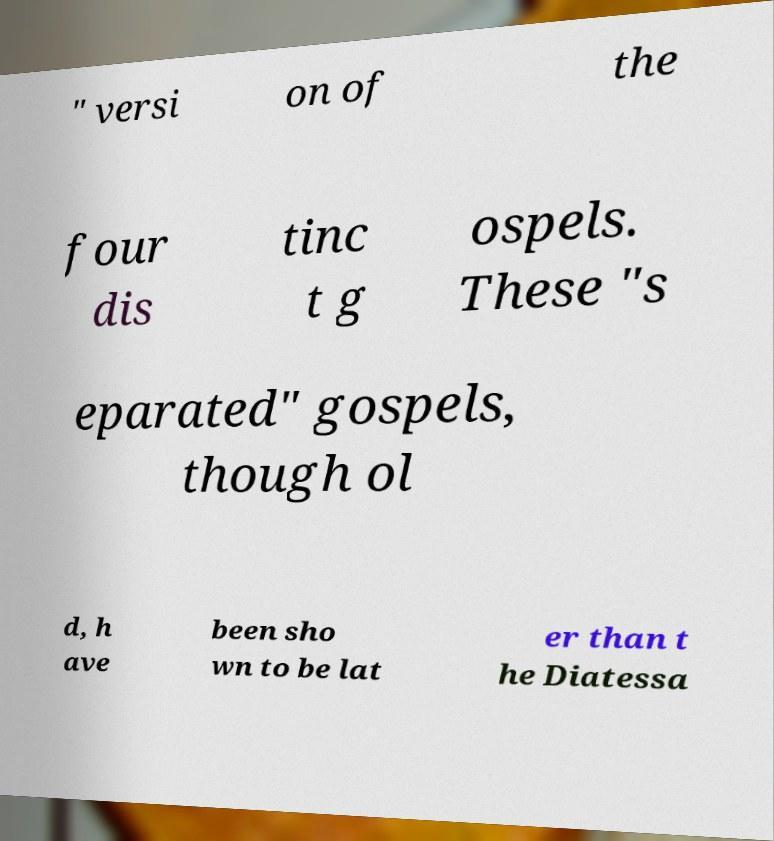What messages or text are displayed in this image? I need them in a readable, typed format. " versi on of the four dis tinc t g ospels. These "s eparated" gospels, though ol d, h ave been sho wn to be lat er than t he Diatessa 